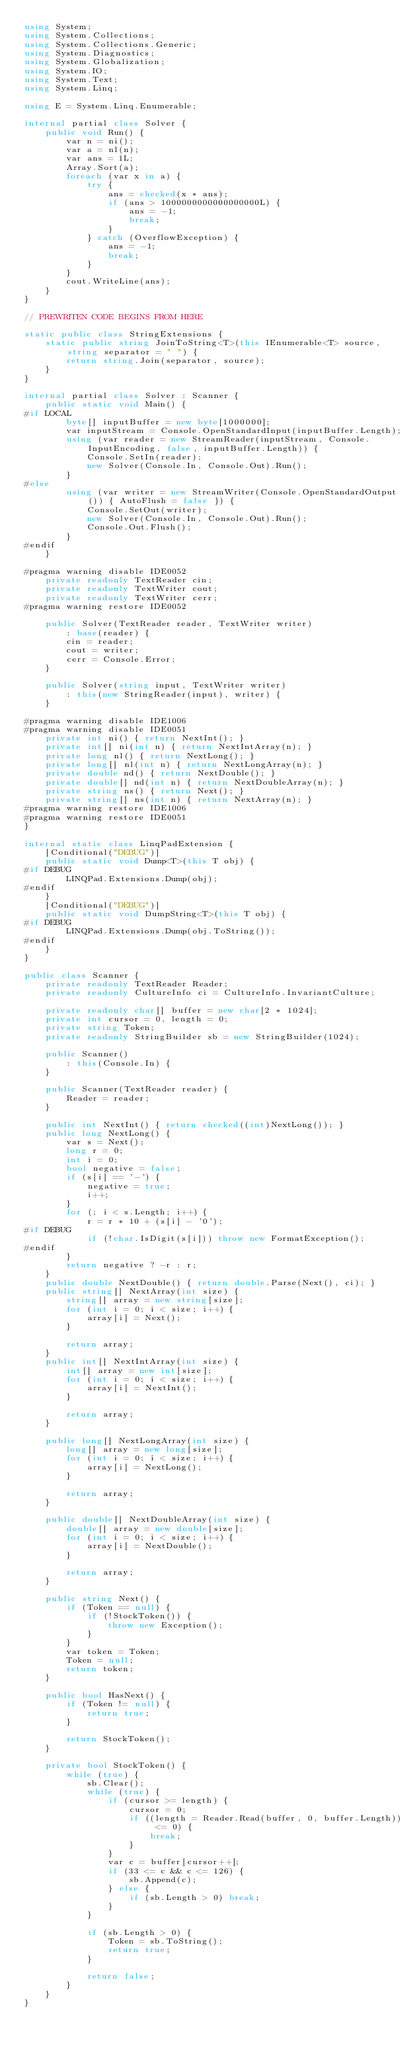Convert code to text. <code><loc_0><loc_0><loc_500><loc_500><_C#_>using System;
using System.Collections;
using System.Collections.Generic;
using System.Diagnostics;
using System.Globalization;
using System.IO;
using System.Text;
using System.Linq;

using E = System.Linq.Enumerable;

internal partial class Solver {
    public void Run() {
        var n = ni();
        var a = nl(n);
        var ans = 1L;
        Array.Sort(a);
        foreach (var x in a) {
            try {
                ans = checked(x * ans);
                if (ans > 1000000000000000000L) {
                    ans = -1;
                    break;
                }
            } catch (OverflowException) {
                ans = -1;
                break;
            }
        }
        cout.WriteLine(ans);
    }
}

// PREWRITEN CODE BEGINS FROM HERE

static public class StringExtensions {
    static public string JoinToString<T>(this IEnumerable<T> source, string separator = " ") {
        return string.Join(separator, source);
    }
}

internal partial class Solver : Scanner {
    public static void Main() {
#if LOCAL
        byte[] inputBuffer = new byte[1000000];
        var inputStream = Console.OpenStandardInput(inputBuffer.Length);
        using (var reader = new StreamReader(inputStream, Console.InputEncoding, false, inputBuffer.Length)) {
            Console.SetIn(reader);
            new Solver(Console.In, Console.Out).Run();
        }
#else
        using (var writer = new StreamWriter(Console.OpenStandardOutput()) { AutoFlush = false }) {
            Console.SetOut(writer);
            new Solver(Console.In, Console.Out).Run();
            Console.Out.Flush();
        }
#endif
    }

#pragma warning disable IDE0052
    private readonly TextReader cin;
    private readonly TextWriter cout;
    private readonly TextWriter cerr;
#pragma warning restore IDE0052

    public Solver(TextReader reader, TextWriter writer)
        : base(reader) {
        cin = reader;
        cout = writer;
        cerr = Console.Error;
    }

    public Solver(string input, TextWriter writer)
        : this(new StringReader(input), writer) {
    }

#pragma warning disable IDE1006
#pragma warning disable IDE0051
    private int ni() { return NextInt(); }
    private int[] ni(int n) { return NextIntArray(n); }
    private long nl() { return NextLong(); }
    private long[] nl(int n) { return NextLongArray(n); }
    private double nd() { return NextDouble(); }
    private double[] nd(int n) { return NextDoubleArray(n); }
    private string ns() { return Next(); }
    private string[] ns(int n) { return NextArray(n); }
#pragma warning restore IDE1006
#pragma warning restore IDE0051
}

internal static class LinqPadExtension {
    [Conditional("DEBUG")]
    public static void Dump<T>(this T obj) {
#if DEBUG
        LINQPad.Extensions.Dump(obj);
#endif
    }
    [Conditional("DEBUG")]
    public static void DumpString<T>(this T obj) {
#if DEBUG
        LINQPad.Extensions.Dump(obj.ToString());
#endif
    }
}

public class Scanner {
    private readonly TextReader Reader;
    private readonly CultureInfo ci = CultureInfo.InvariantCulture;

    private readonly char[] buffer = new char[2 * 1024];
    private int cursor = 0, length = 0;
    private string Token;
    private readonly StringBuilder sb = new StringBuilder(1024);

    public Scanner()
        : this(Console.In) {
    }

    public Scanner(TextReader reader) {
        Reader = reader;
    }

    public int NextInt() { return checked((int)NextLong()); }
    public long NextLong() {
        var s = Next();
        long r = 0;
        int i = 0;
        bool negative = false;
        if (s[i] == '-') {
            negative = true;
            i++;
        }
        for (; i < s.Length; i++) {
            r = r * 10 + (s[i] - '0');
#if DEBUG
            if (!char.IsDigit(s[i])) throw new FormatException();
#endif
        }
        return negative ? -r : r;
    }
    public double NextDouble() { return double.Parse(Next(), ci); }
    public string[] NextArray(int size) {
        string[] array = new string[size];
        for (int i = 0; i < size; i++) {
            array[i] = Next();
        }

        return array;
    }
    public int[] NextIntArray(int size) {
        int[] array = new int[size];
        for (int i = 0; i < size; i++) {
            array[i] = NextInt();
        }

        return array;
    }

    public long[] NextLongArray(int size) {
        long[] array = new long[size];
        for (int i = 0; i < size; i++) {
            array[i] = NextLong();
        }

        return array;
    }

    public double[] NextDoubleArray(int size) {
        double[] array = new double[size];
        for (int i = 0; i < size; i++) {
            array[i] = NextDouble();
        }

        return array;
    }

    public string Next() {
        if (Token == null) {
            if (!StockToken()) {
                throw new Exception();
            }
        }
        var token = Token;
        Token = null;
        return token;
    }

    public bool HasNext() {
        if (Token != null) {
            return true;
        }

        return StockToken();
    }

    private bool StockToken() {
        while (true) {
            sb.Clear();
            while (true) {
                if (cursor >= length) {
                    cursor = 0;
                    if ((length = Reader.Read(buffer, 0, buffer.Length)) <= 0) {
                        break;
                    }
                }
                var c = buffer[cursor++];
                if (33 <= c && c <= 126) {
                    sb.Append(c);
                } else {
                    if (sb.Length > 0) break;
                }
            }

            if (sb.Length > 0) {
                Token = sb.ToString();
                return true;
            }

            return false;
        }
    }
}</code> 